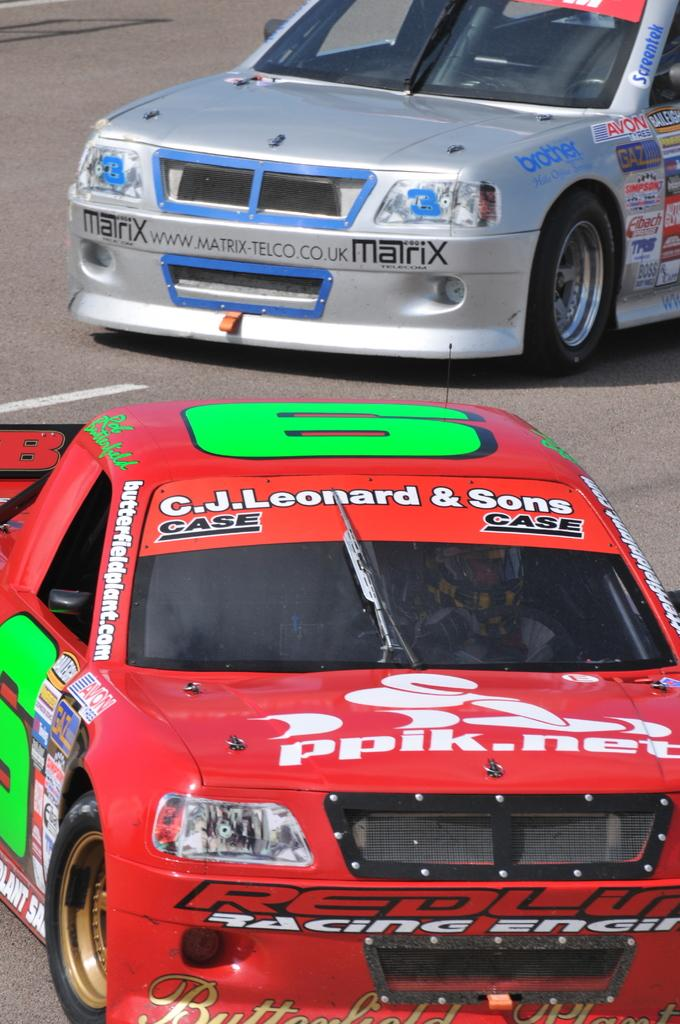How many cars are visible in the image? There are two cars in the image. What are the cars doing in the image? The cars are passing on the road. What type of wool is being used to insulate the oven in the image? There is no oven or wool present in the image; it features two cars passing on the road. 